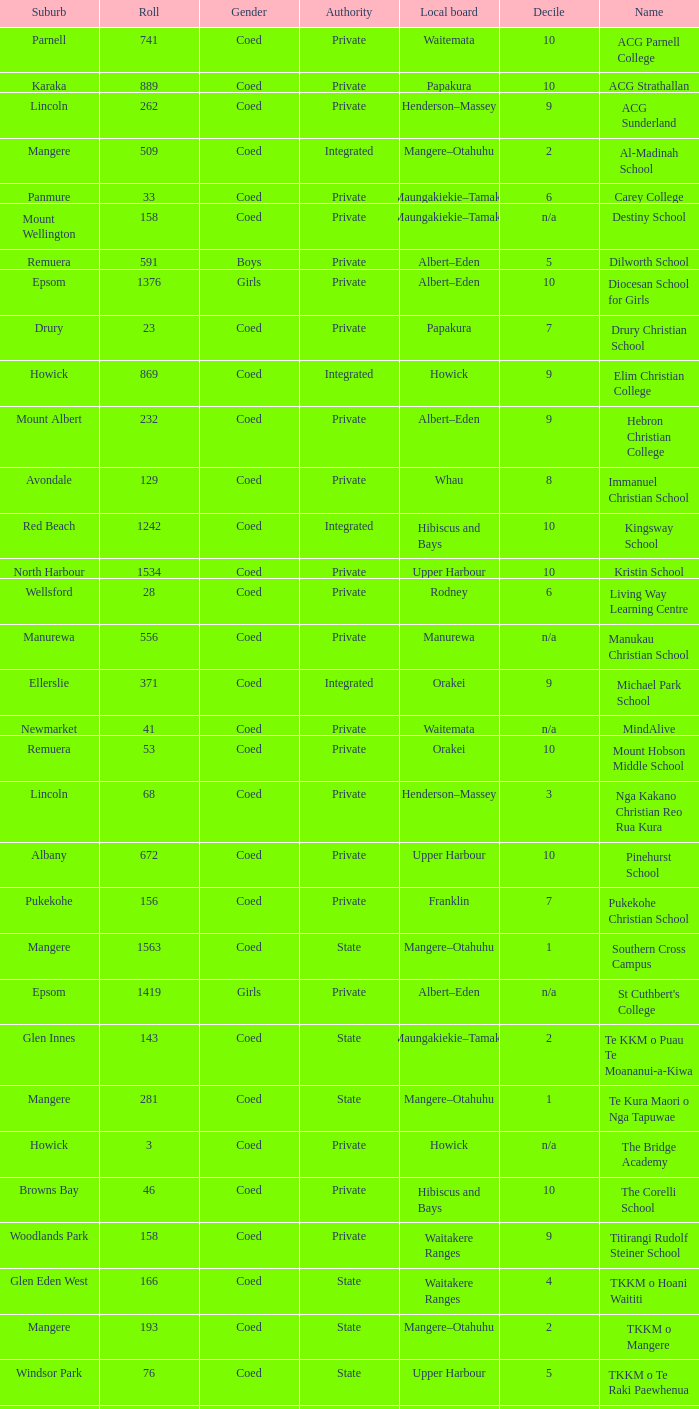What is the name of the suburb with a roll of 741? Parnell. 